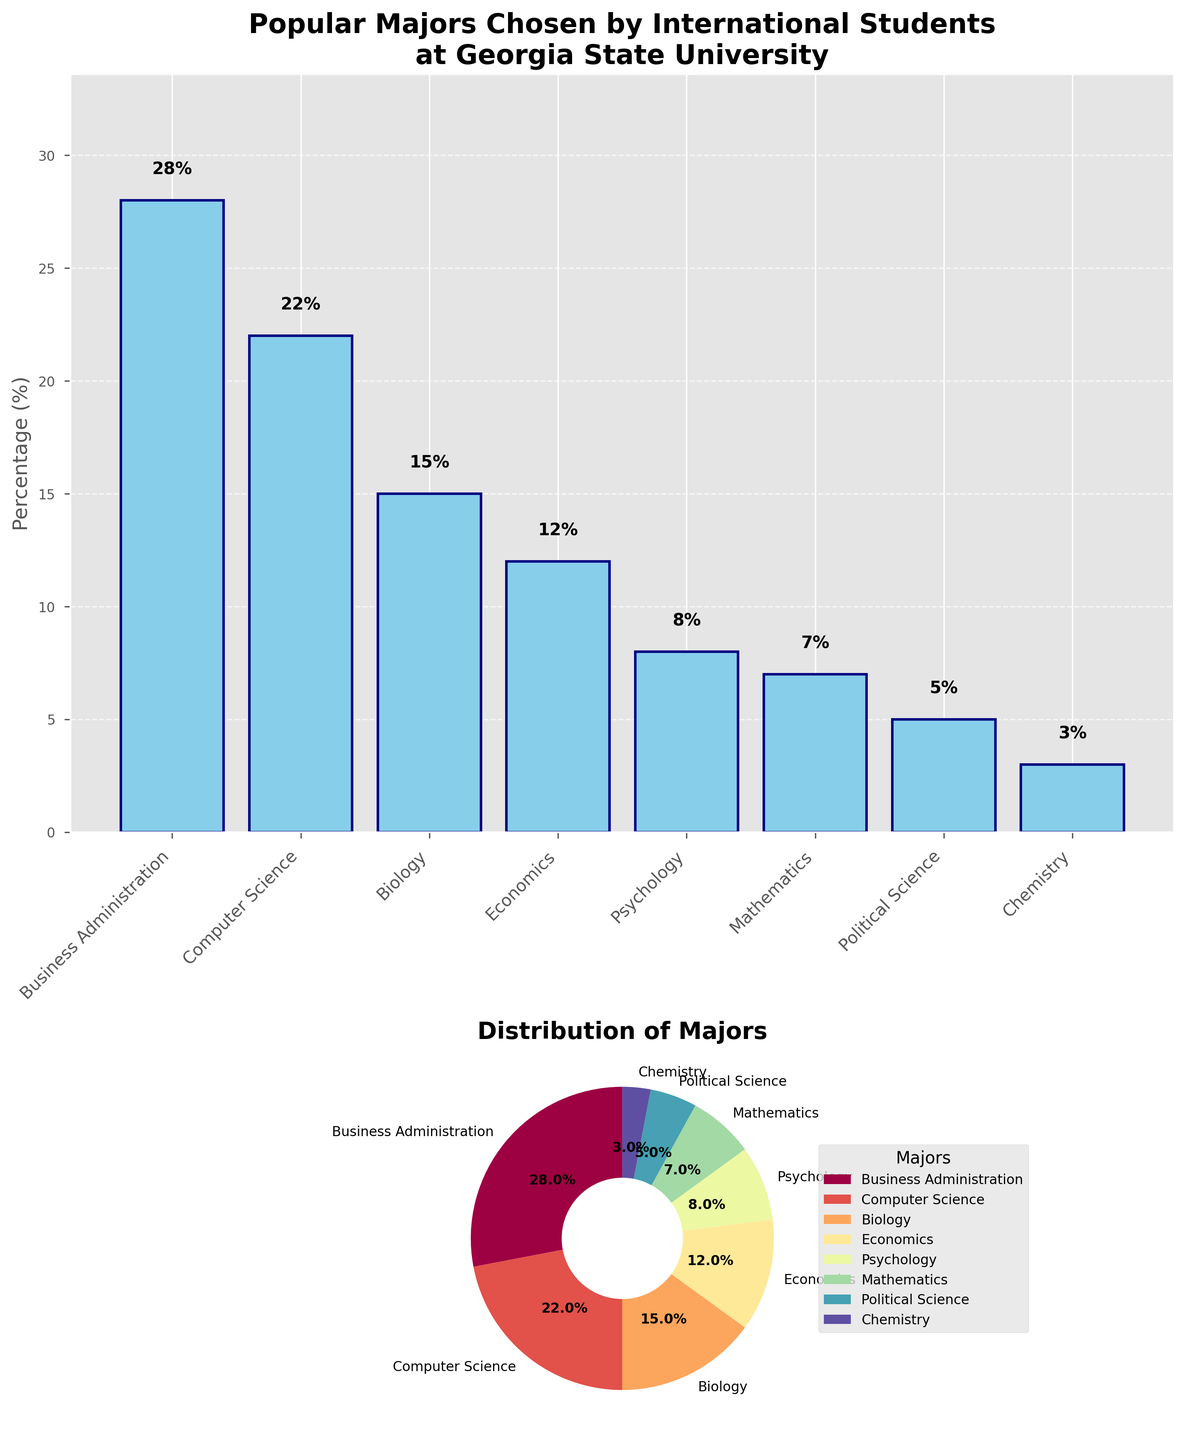What is the title of the bar plot? The title of the bar plot is displayed at the top and reads "Popular Majors Chosen by International Students\nat Georgia State University".
Answer: "Popular Majors Chosen by International Students\nat Georgia State University" What is the percentage of international students who chose Computer Science? The bar plot shows "Computer Science" along the x-axis, and the corresponding bar reaches up to 22% on the y-axis. Additionally, the percentage value is annotated above the bar as "22%".
Answer: 22% Which major has the smallest percentage of international students? The bar plot reveals that the "Chemistry" bar is the shortest, and in both bar and pie charts, the percentage for Chemistry is annotated as 3%.
Answer: Chemistry How many majors have a percentage of 10% or higher? By examining both the bar and pie charts, we can identify that "Business Administration", "Computer Science", "Biology", and "Economics" have percentages of 28%, 22%, 15%, and 12%, respectively, each of which is 10% or higher. There are 4 such majors.
Answer: 4 What is the combined percentage of students in Mathematics and Political Science? From the bar chart, Mathematics has a percentage of 7% and Political Science has 5%. Adding these together gives 7% + 5% = 12%.
Answer: 12% Which major has a larger percentage: Biology or Psychology? From both the bar and pie charts, we can see that Biology has a percentage of 15%, while Psychology has 8%. Therefore, Biology has a larger percentage than Psychology.
Answer: Biology How does the percentage of Economics compare to that of Mathematics? Economics has a percentage of 12%, and Mathematics has 7% on both the bar and pie charts. Thus, the percentage for Economics is greater than that for Mathematics.
Answer: greater What is the percentage difference between Business Administration and Chemistry? Business Administration has a percentage of 28%, and Chemistry has 3%. Subtracting these gives 28% - 3% = 25%.
Answer: 25% What are the y-axis limits set in the bar plot? The y-axis of the bar plot ranges from 0% to a limit slightly higher than the highest percentage value (28%), which is set at 34% (1.2 times 28%).
Answer: 0% to 34% Which major would you find between Biology and Psychology on the pie chart if following clockwise? In the pie chart, starting from Biology at 15% and moving clockwise, the next segment represents Economics at 12% before reaching Psychology at 8%.
Answer: Economics 